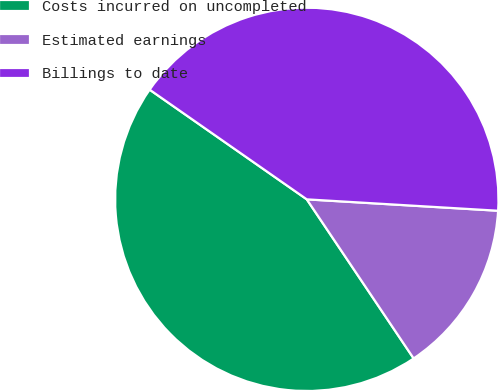<chart> <loc_0><loc_0><loc_500><loc_500><pie_chart><fcel>Costs incurred on uncompleted<fcel>Estimated earnings<fcel>Billings to date<nl><fcel>44.11%<fcel>14.64%<fcel>41.25%<nl></chart> 